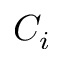Convert formula to latex. <formula><loc_0><loc_0><loc_500><loc_500>C _ { i }</formula> 